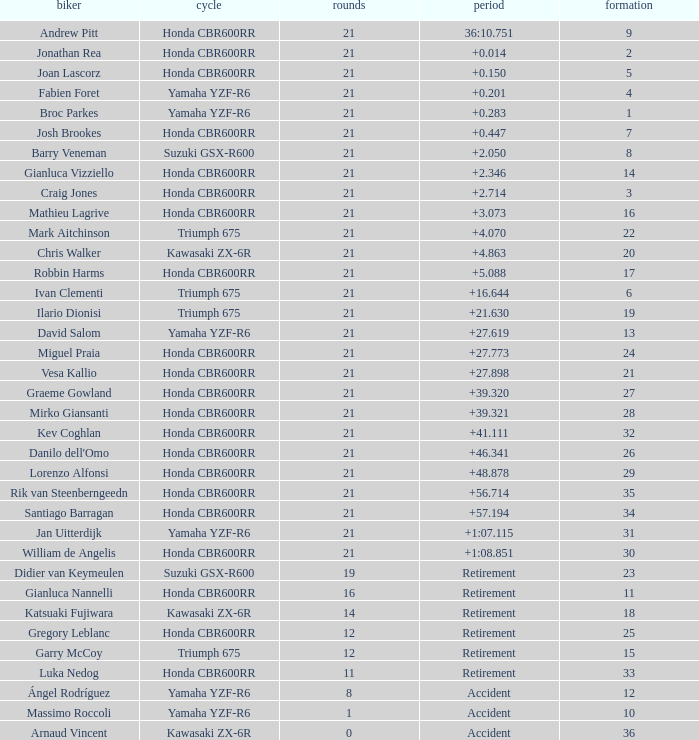What is the driver with the laps under 16, grid of 10, a bike of Yamaha YZF-R6, and ended with an accident? Massimo Roccoli. 